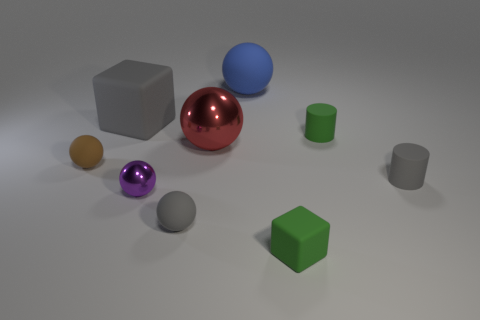There is a rubber object that is to the right of the big blue rubber sphere and behind the red ball; what is its shape? The rubber object in question appears to be a cylindrical shape; it has a circular base with a height longer than its diameter, characteristic of cylinders. 